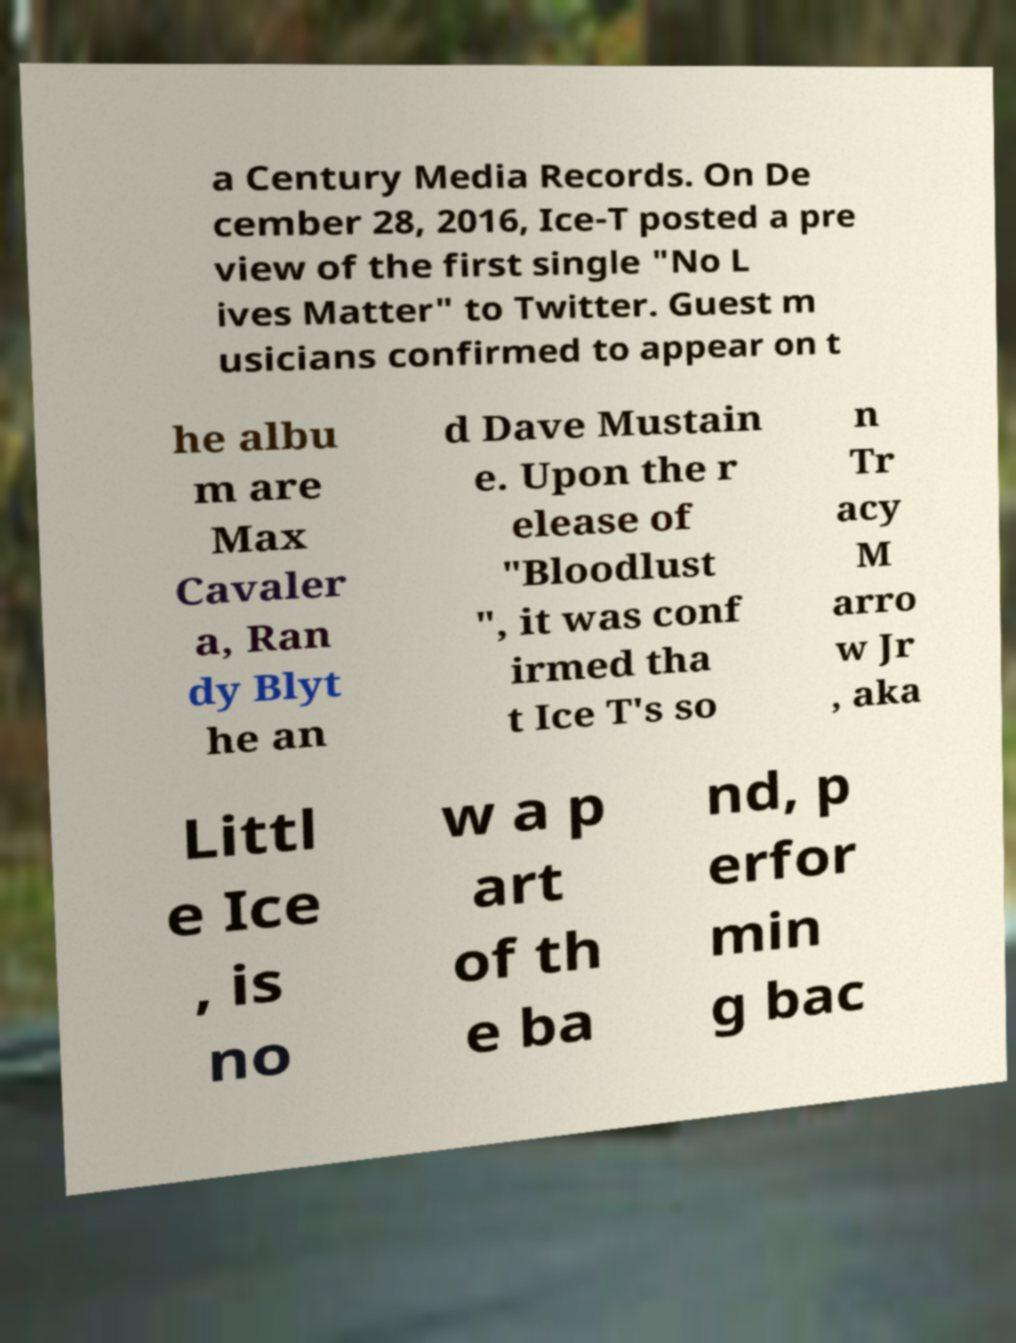What messages or text are displayed in this image? I need them in a readable, typed format. a Century Media Records. On De cember 28, 2016, Ice-T posted a pre view of the first single "No L ives Matter" to Twitter. Guest m usicians confirmed to appear on t he albu m are Max Cavaler a, Ran dy Blyt he an d Dave Mustain e. Upon the r elease of "Bloodlust ", it was conf irmed tha t Ice T's so n Tr acy M arro w Jr , aka Littl e Ice , is no w a p art of th e ba nd, p erfor min g bac 